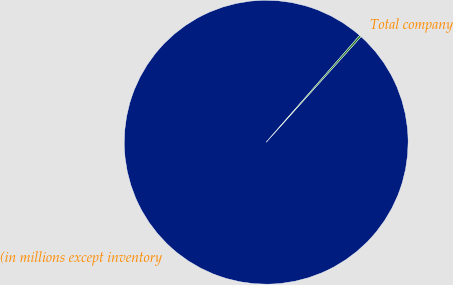Convert chart. <chart><loc_0><loc_0><loc_500><loc_500><pie_chart><fcel>(in millions except inventory<fcel>Total company<nl><fcel>99.79%<fcel>0.21%<nl></chart> 